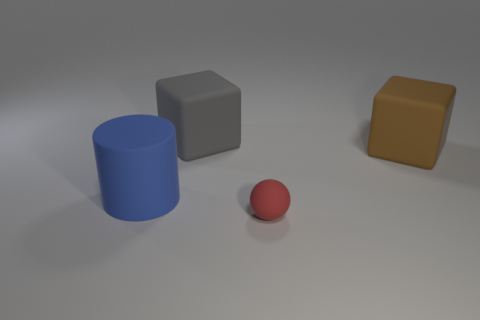What is the material of the blue thing? Based on the appearance in the image, the blue object resembles a typical cylindrical shape made from a material that could be either plastic or a matte-type rubber. It's difficult to determine the exact material with certainty without additional context or tactile information. 